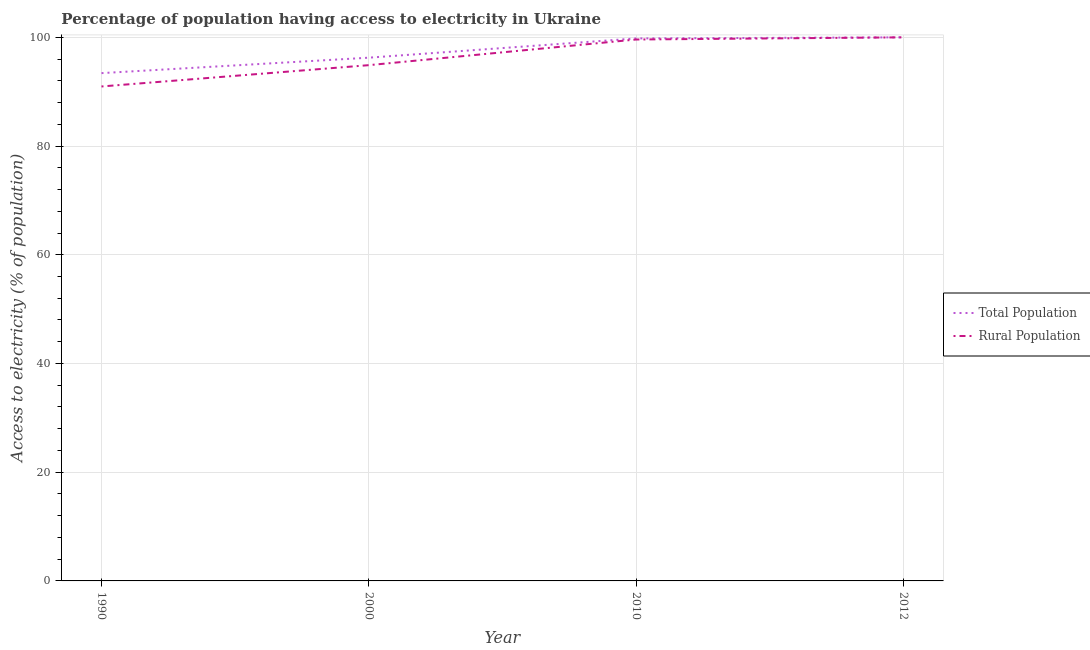How many different coloured lines are there?
Ensure brevity in your answer.  2. What is the percentage of population having access to electricity in 2000?
Keep it short and to the point. 96.26. Across all years, what is the minimum percentage of population having access to electricity?
Your answer should be very brief. 93.42. In which year was the percentage of population having access to electricity maximum?
Your answer should be compact. 2012. In which year was the percentage of population having access to electricity minimum?
Make the answer very short. 1990. What is the total percentage of population having access to electricity in the graph?
Your answer should be compact. 389.47. What is the difference between the percentage of population having access to electricity in 1990 and that in 2010?
Keep it short and to the point. -6.38. What is the difference between the percentage of rural population having access to electricity in 2000 and the percentage of population having access to electricity in 2012?
Offer a terse response. -5.12. What is the average percentage of rural population having access to electricity per year?
Ensure brevity in your answer.  96.36. In the year 2010, what is the difference between the percentage of rural population having access to electricity and percentage of population having access to electricity?
Ensure brevity in your answer.  -0.2. In how many years, is the percentage of rural population having access to electricity greater than 76 %?
Offer a very short reply. 4. What is the ratio of the percentage of rural population having access to electricity in 1990 to that in 2000?
Ensure brevity in your answer.  0.96. Is the percentage of population having access to electricity in 1990 less than that in 2012?
Make the answer very short. Yes. Is the difference between the percentage of rural population having access to electricity in 2010 and 2012 greater than the difference between the percentage of population having access to electricity in 2010 and 2012?
Provide a short and direct response. No. What is the difference between the highest and the second highest percentage of rural population having access to electricity?
Provide a short and direct response. 0.4. What is the difference between the highest and the lowest percentage of rural population having access to electricity?
Provide a short and direct response. 9.04. Does the percentage of rural population having access to electricity monotonically increase over the years?
Your answer should be very brief. Yes. How many lines are there?
Ensure brevity in your answer.  2. How many years are there in the graph?
Your answer should be compact. 4. What is the difference between two consecutive major ticks on the Y-axis?
Ensure brevity in your answer.  20. Are the values on the major ticks of Y-axis written in scientific E-notation?
Offer a terse response. No. Does the graph contain any zero values?
Provide a succinct answer. No. Does the graph contain grids?
Provide a short and direct response. Yes. What is the title of the graph?
Keep it short and to the point. Percentage of population having access to electricity in Ukraine. Does "Personal remittances" appear as one of the legend labels in the graph?
Make the answer very short. No. What is the label or title of the X-axis?
Provide a succinct answer. Year. What is the label or title of the Y-axis?
Provide a succinct answer. Access to electricity (% of population). What is the Access to electricity (% of population) in Total Population in 1990?
Give a very brief answer. 93.42. What is the Access to electricity (% of population) of Rural Population in 1990?
Offer a terse response. 90.96. What is the Access to electricity (% of population) of Total Population in 2000?
Provide a short and direct response. 96.26. What is the Access to electricity (% of population) in Rural Population in 2000?
Ensure brevity in your answer.  94.88. What is the Access to electricity (% of population) of Total Population in 2010?
Make the answer very short. 99.8. What is the Access to electricity (% of population) of Rural Population in 2010?
Your response must be concise. 99.6. What is the Access to electricity (% of population) in Rural Population in 2012?
Provide a short and direct response. 100. Across all years, what is the minimum Access to electricity (% of population) in Total Population?
Your answer should be compact. 93.42. Across all years, what is the minimum Access to electricity (% of population) in Rural Population?
Your answer should be compact. 90.96. What is the total Access to electricity (% of population) in Total Population in the graph?
Your answer should be very brief. 389.47. What is the total Access to electricity (% of population) of Rural Population in the graph?
Offer a terse response. 385.44. What is the difference between the Access to electricity (% of population) in Total Population in 1990 and that in 2000?
Your response must be concise. -2.84. What is the difference between the Access to electricity (% of population) in Rural Population in 1990 and that in 2000?
Offer a very short reply. -3.92. What is the difference between the Access to electricity (% of population) in Total Population in 1990 and that in 2010?
Your answer should be very brief. -6.38. What is the difference between the Access to electricity (% of population) in Rural Population in 1990 and that in 2010?
Give a very brief answer. -8.64. What is the difference between the Access to electricity (% of population) in Total Population in 1990 and that in 2012?
Your response must be concise. -6.58. What is the difference between the Access to electricity (% of population) in Rural Population in 1990 and that in 2012?
Ensure brevity in your answer.  -9.04. What is the difference between the Access to electricity (% of population) of Total Population in 2000 and that in 2010?
Offer a very short reply. -3.54. What is the difference between the Access to electricity (% of population) in Rural Population in 2000 and that in 2010?
Your response must be concise. -4.72. What is the difference between the Access to electricity (% of population) in Total Population in 2000 and that in 2012?
Offer a terse response. -3.74. What is the difference between the Access to electricity (% of population) in Rural Population in 2000 and that in 2012?
Your answer should be very brief. -5.12. What is the difference between the Access to electricity (% of population) in Total Population in 1990 and the Access to electricity (% of population) in Rural Population in 2000?
Ensure brevity in your answer.  -1.47. What is the difference between the Access to electricity (% of population) of Total Population in 1990 and the Access to electricity (% of population) of Rural Population in 2010?
Provide a short and direct response. -6.18. What is the difference between the Access to electricity (% of population) of Total Population in 1990 and the Access to electricity (% of population) of Rural Population in 2012?
Ensure brevity in your answer.  -6.58. What is the difference between the Access to electricity (% of population) in Total Population in 2000 and the Access to electricity (% of population) in Rural Population in 2010?
Your response must be concise. -3.34. What is the difference between the Access to electricity (% of population) of Total Population in 2000 and the Access to electricity (% of population) of Rural Population in 2012?
Your answer should be compact. -3.74. What is the difference between the Access to electricity (% of population) of Total Population in 2010 and the Access to electricity (% of population) of Rural Population in 2012?
Your answer should be very brief. -0.2. What is the average Access to electricity (% of population) of Total Population per year?
Provide a short and direct response. 97.37. What is the average Access to electricity (% of population) of Rural Population per year?
Your answer should be very brief. 96.36. In the year 1990, what is the difference between the Access to electricity (% of population) in Total Population and Access to electricity (% of population) in Rural Population?
Ensure brevity in your answer.  2.46. In the year 2000, what is the difference between the Access to electricity (% of population) in Total Population and Access to electricity (% of population) in Rural Population?
Ensure brevity in your answer.  1.38. In the year 2010, what is the difference between the Access to electricity (% of population) in Total Population and Access to electricity (% of population) in Rural Population?
Offer a very short reply. 0.2. In the year 2012, what is the difference between the Access to electricity (% of population) of Total Population and Access to electricity (% of population) of Rural Population?
Ensure brevity in your answer.  0. What is the ratio of the Access to electricity (% of population) of Total Population in 1990 to that in 2000?
Offer a terse response. 0.97. What is the ratio of the Access to electricity (% of population) in Rural Population in 1990 to that in 2000?
Make the answer very short. 0.96. What is the ratio of the Access to electricity (% of population) in Total Population in 1990 to that in 2010?
Your response must be concise. 0.94. What is the ratio of the Access to electricity (% of population) of Rural Population in 1990 to that in 2010?
Ensure brevity in your answer.  0.91. What is the ratio of the Access to electricity (% of population) in Total Population in 1990 to that in 2012?
Your answer should be compact. 0.93. What is the ratio of the Access to electricity (% of population) of Rural Population in 1990 to that in 2012?
Your answer should be compact. 0.91. What is the ratio of the Access to electricity (% of population) in Total Population in 2000 to that in 2010?
Make the answer very short. 0.96. What is the ratio of the Access to electricity (% of population) in Rural Population in 2000 to that in 2010?
Offer a terse response. 0.95. What is the ratio of the Access to electricity (% of population) in Total Population in 2000 to that in 2012?
Your answer should be compact. 0.96. What is the ratio of the Access to electricity (% of population) of Rural Population in 2000 to that in 2012?
Give a very brief answer. 0.95. What is the difference between the highest and the second highest Access to electricity (% of population) of Rural Population?
Offer a terse response. 0.4. What is the difference between the highest and the lowest Access to electricity (% of population) of Total Population?
Provide a succinct answer. 6.58. What is the difference between the highest and the lowest Access to electricity (% of population) in Rural Population?
Your response must be concise. 9.04. 